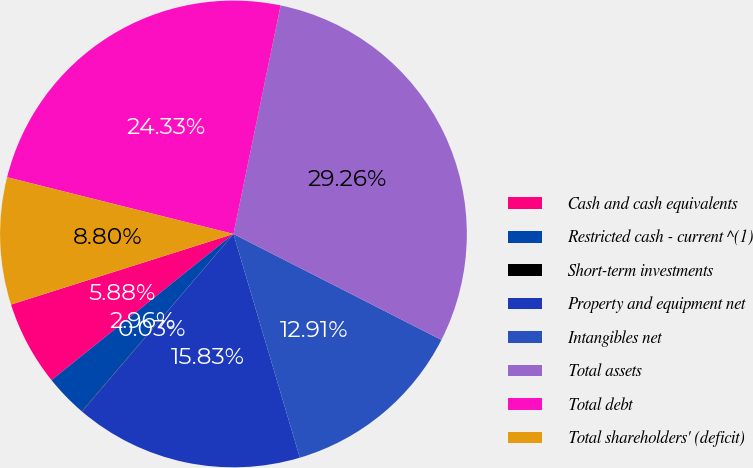<chart> <loc_0><loc_0><loc_500><loc_500><pie_chart><fcel>Cash and cash equivalents<fcel>Restricted cash - current ^(1)<fcel>Short-term investments<fcel>Property and equipment net<fcel>Intangibles net<fcel>Total assets<fcel>Total debt<fcel>Total shareholders' (deficit)<nl><fcel>5.88%<fcel>2.96%<fcel>0.03%<fcel>15.83%<fcel>12.91%<fcel>29.26%<fcel>24.33%<fcel>8.8%<nl></chart> 